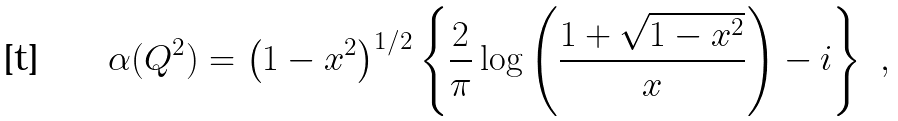<formula> <loc_0><loc_0><loc_500><loc_500>\alpha ( Q ^ { 2 } ) = \left ( 1 - x ^ { 2 } \right ) ^ { 1 / 2 } \left \{ \frac { 2 } { \pi } \log \left ( \frac { 1 + \sqrt { 1 - x ^ { 2 } } } { x } \right ) - i \right \} \ ,</formula> 